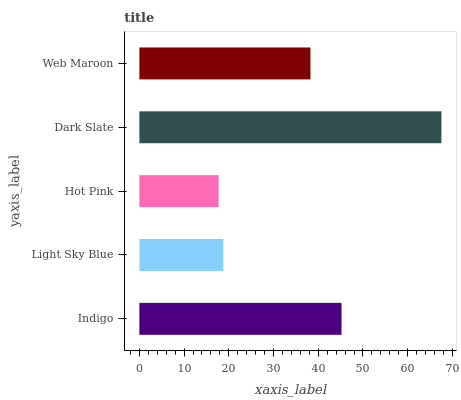Is Hot Pink the minimum?
Answer yes or no. Yes. Is Dark Slate the maximum?
Answer yes or no. Yes. Is Light Sky Blue the minimum?
Answer yes or no. No. Is Light Sky Blue the maximum?
Answer yes or no. No. Is Indigo greater than Light Sky Blue?
Answer yes or no. Yes. Is Light Sky Blue less than Indigo?
Answer yes or no. Yes. Is Light Sky Blue greater than Indigo?
Answer yes or no. No. Is Indigo less than Light Sky Blue?
Answer yes or no. No. Is Web Maroon the high median?
Answer yes or no. Yes. Is Web Maroon the low median?
Answer yes or no. Yes. Is Indigo the high median?
Answer yes or no. No. Is Indigo the low median?
Answer yes or no. No. 